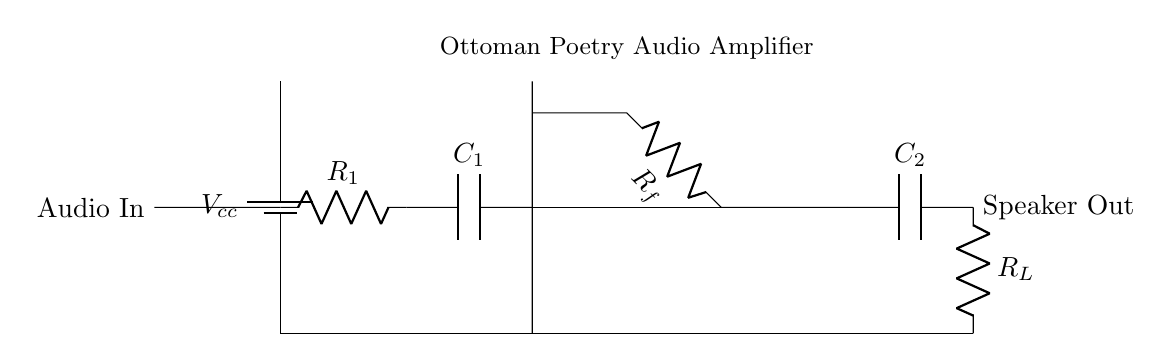What is the power supply voltage in this circuit? The circuit includes a battery labeled Vcc, which represents the power supply voltage. However, the specific value is not given.
Answer: Vcc What type of amplifier is used in this circuit? The circuit diagram features an operational amplifier (op amp) indicated by its symbol. Operational amplifiers are commonly used for various amplification tasks.
Answer: Operational amplifier What is the function of capacitor C1? C1 is positioned between the resistor R1 and the input of the op amp, suggesting it functions as a coupling capacitor. Its role is to allow AC signals to pass while blocking DC components.
Answer: Coupling capacitor Which component provides feedback to the amplifier? The feedback loop is established by the resistor labeled Rf, connecting output back to a point before the input of the op amp. This negative feedback helps stabilize and control the gain of the amplifier.
Answer: Rf What is the load resistor used in the output stage? R_L is labeled as the load resistor at the output of the circuit, which connects to the speaker, modifying the output signal's characteristics according to the speaker's specifications.
Answer: R_L 